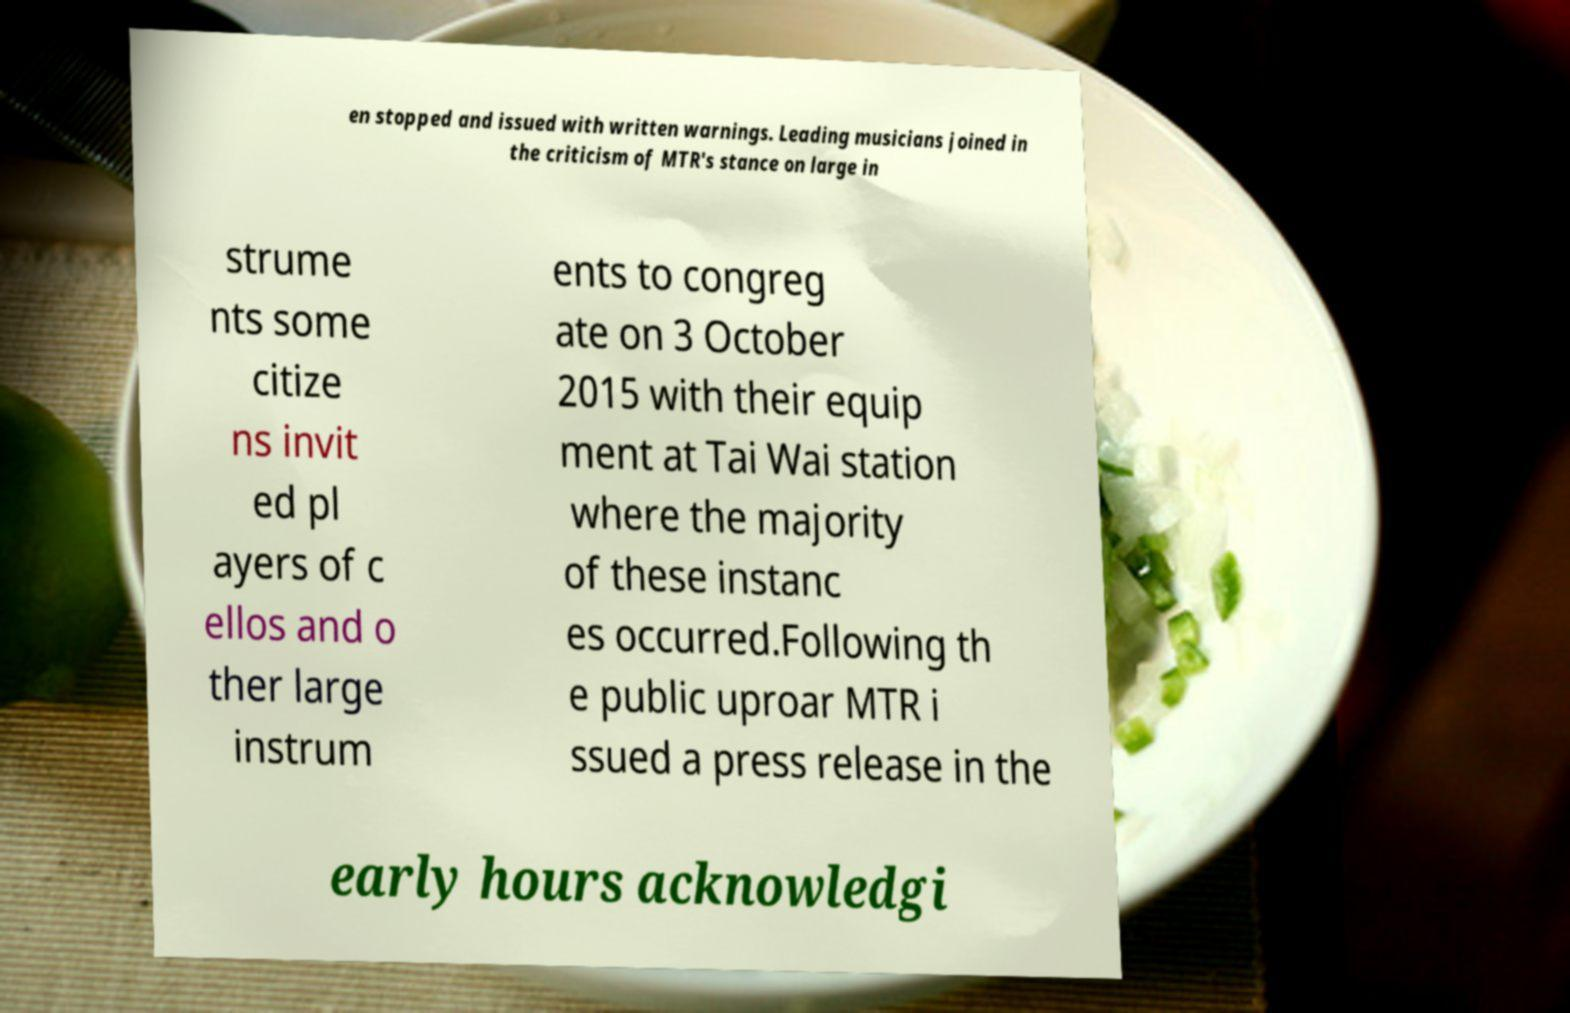For documentation purposes, I need the text within this image transcribed. Could you provide that? en stopped and issued with written warnings. Leading musicians joined in the criticism of MTR's stance on large in strume nts some citize ns invit ed pl ayers of c ellos and o ther large instrum ents to congreg ate on 3 October 2015 with their equip ment at Tai Wai station where the majority of these instanc es occurred.Following th e public uproar MTR i ssued a press release in the early hours acknowledgi 